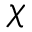<formula> <loc_0><loc_0><loc_500><loc_500>\chi</formula> 